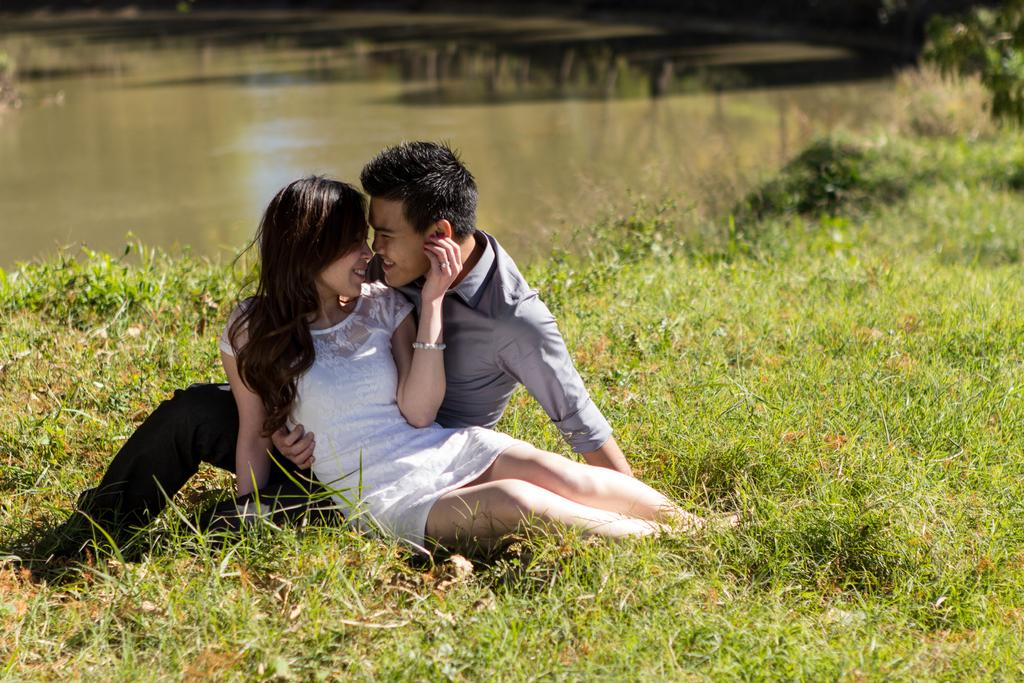Who is present in the image? There is a couple in the image. What are they doing in the image? The couple is sitting on the grass. What can be seen in the background of the image? There is water visible in the background of the image. What type of bells can be heard ringing in the image? There are no bells present in the image, and therefore no sound can be heard. 